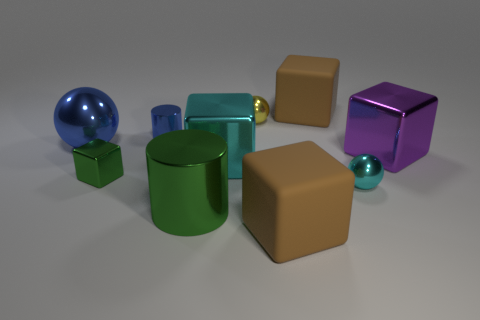Subtract 2 blocks. How many blocks are left? 3 Subtract all purple cubes. Subtract all red cylinders. How many cubes are left? 4 Subtract all cylinders. How many objects are left? 8 Subtract all metallic cylinders. Subtract all yellow things. How many objects are left? 7 Add 8 big rubber blocks. How many big rubber blocks are left? 10 Add 2 small purple rubber cylinders. How many small purple rubber cylinders exist? 2 Subtract 0 green balls. How many objects are left? 10 